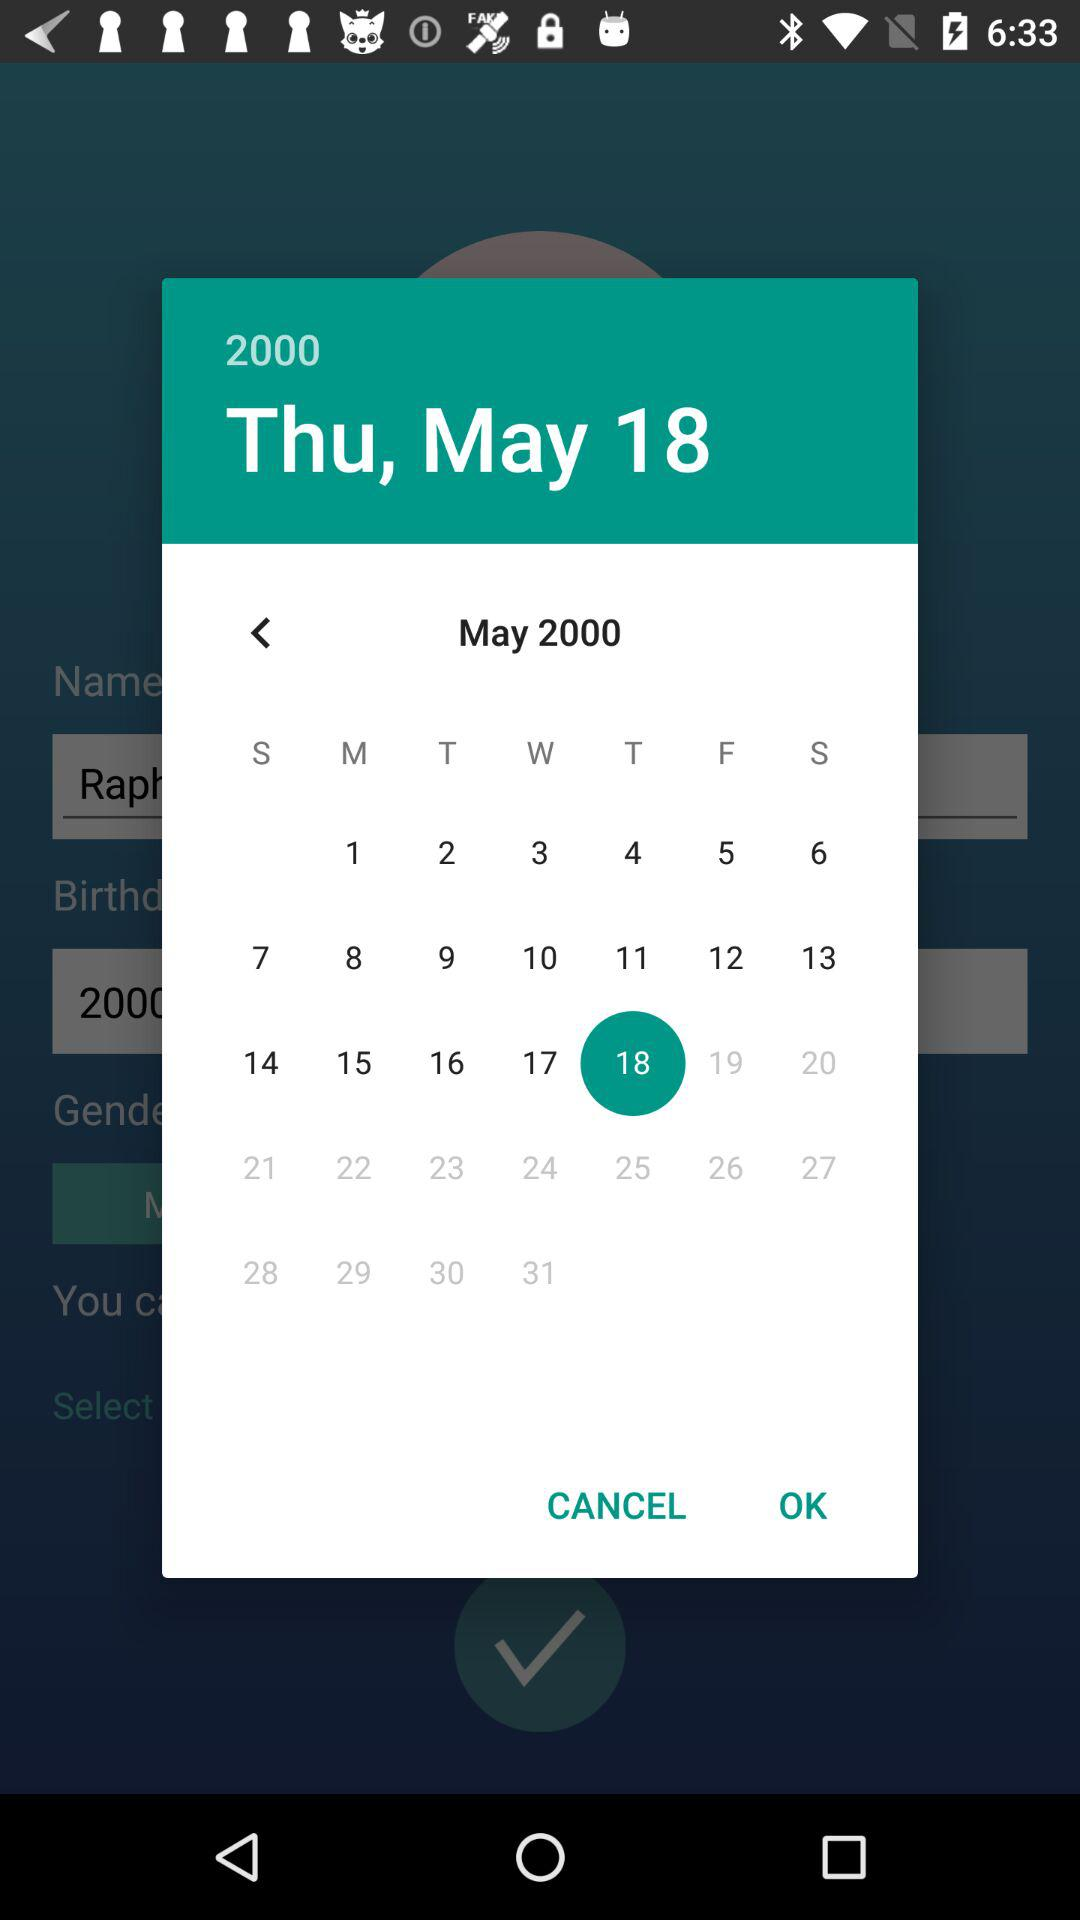What is the date that has been chosen? The date is Thursday, May 18, 2016. 